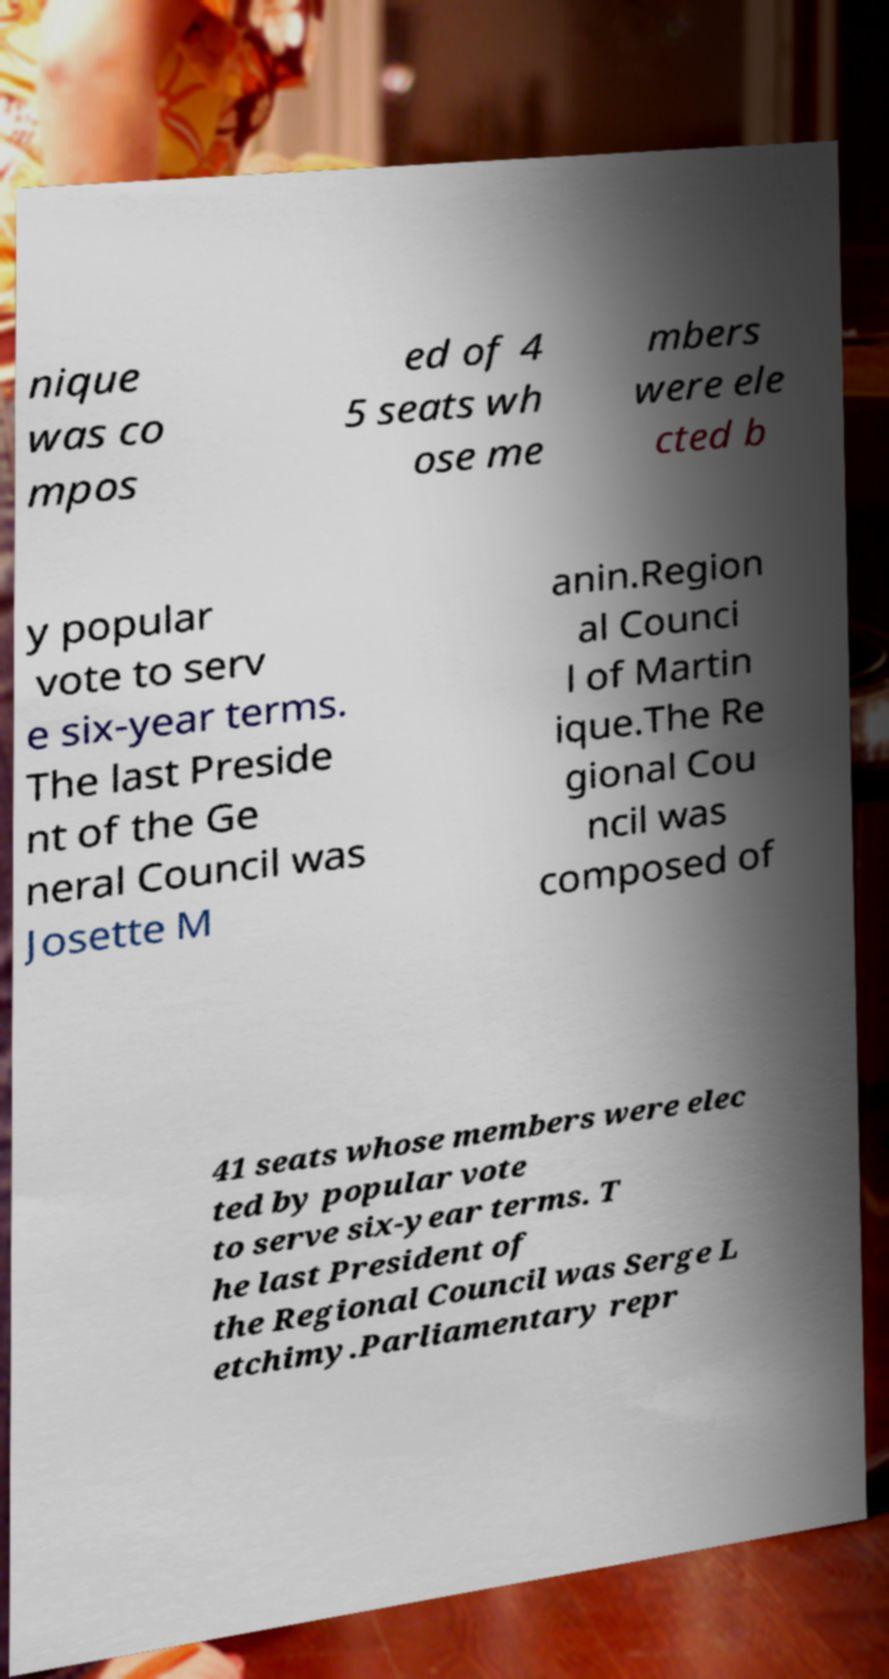Please identify and transcribe the text found in this image. nique was co mpos ed of 4 5 seats wh ose me mbers were ele cted b y popular vote to serv e six-year terms. The last Preside nt of the Ge neral Council was Josette M anin.Region al Counci l of Martin ique.The Re gional Cou ncil was composed of 41 seats whose members were elec ted by popular vote to serve six-year terms. T he last President of the Regional Council was Serge L etchimy.Parliamentary repr 